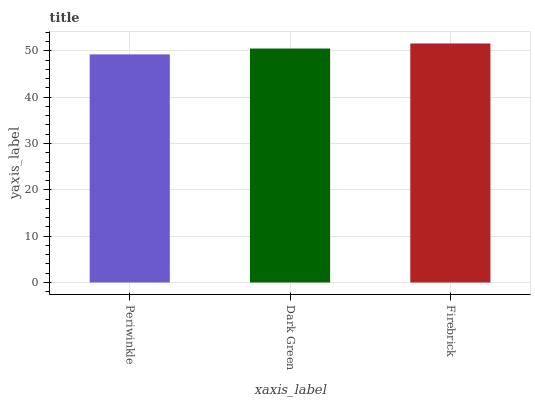Is Dark Green the minimum?
Answer yes or no. No. Is Dark Green the maximum?
Answer yes or no. No. Is Dark Green greater than Periwinkle?
Answer yes or no. Yes. Is Periwinkle less than Dark Green?
Answer yes or no. Yes. Is Periwinkle greater than Dark Green?
Answer yes or no. No. Is Dark Green less than Periwinkle?
Answer yes or no. No. Is Dark Green the high median?
Answer yes or no. Yes. Is Dark Green the low median?
Answer yes or no. Yes. Is Firebrick the high median?
Answer yes or no. No. Is Firebrick the low median?
Answer yes or no. No. 